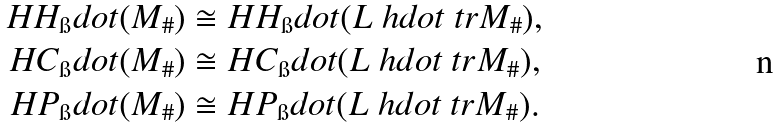Convert formula to latex. <formula><loc_0><loc_0><loc_500><loc_500>H H _ { \i } d o t ( M _ { \# } ) & \cong H H _ { \i } d o t ( L ^ { \ } h d o t \ t r M _ { \# } ) , \\ H C _ { \i } d o t ( M _ { \# } ) & \cong H C _ { \i } d o t ( L ^ { \ } h d o t \ t r M _ { \# } ) , \\ H P _ { \i } d o t ( M _ { \# } ) & \cong H P _ { \i } d o t ( L ^ { \ } h d o t \ t r M _ { \# } ) .</formula> 